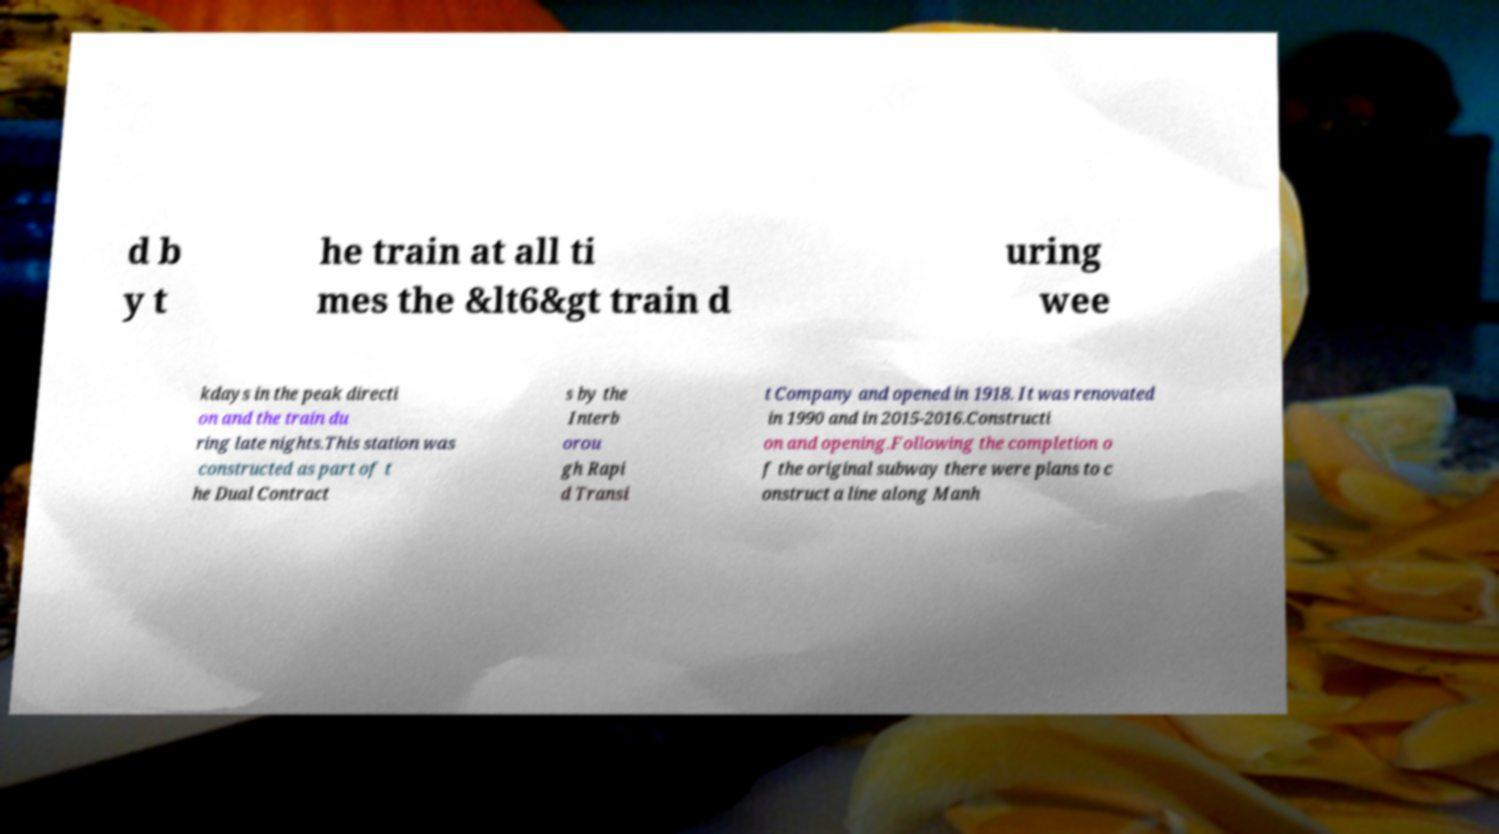Please identify and transcribe the text found in this image. d b y t he train at all ti mes the &lt6&gt train d uring wee kdays in the peak directi on and the train du ring late nights.This station was constructed as part of t he Dual Contract s by the Interb orou gh Rapi d Transi t Company and opened in 1918. It was renovated in 1990 and in 2015-2016.Constructi on and opening.Following the completion o f the original subway there were plans to c onstruct a line along Manh 